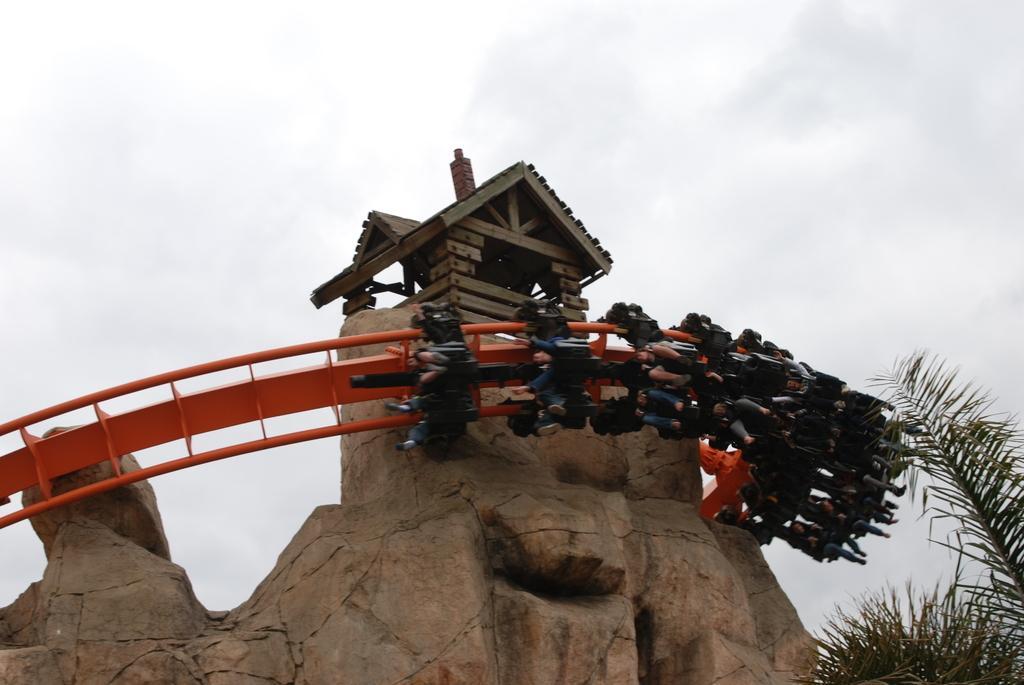How would you summarize this image in a sentence or two? In this picture I can see group of people riding a roller coaster, there are trees, this is looking a small wooden house, and in the background there is sky. 